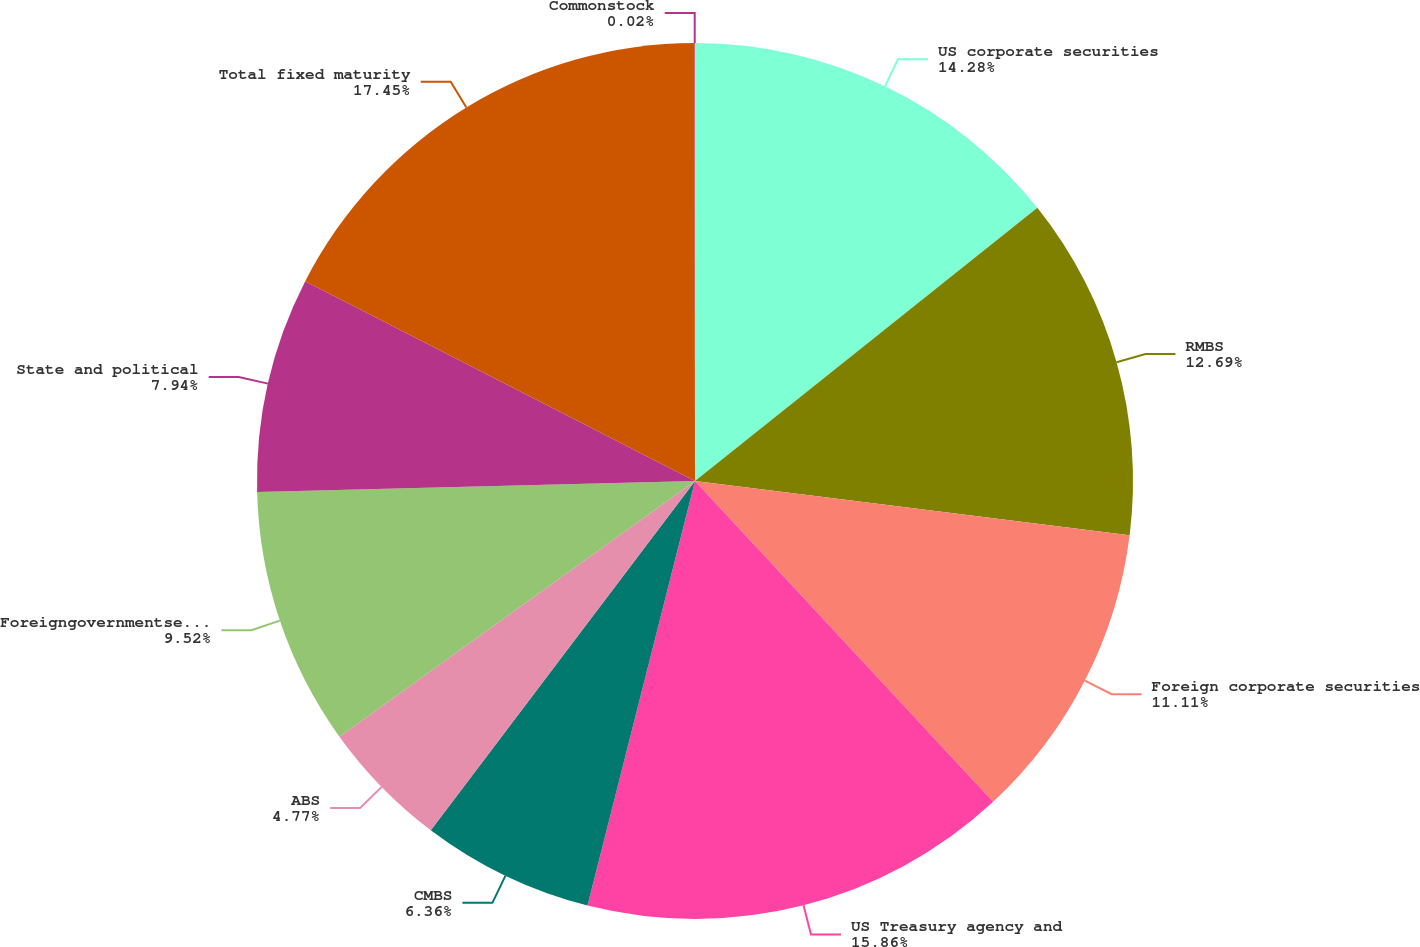Convert chart to OTSL. <chart><loc_0><loc_0><loc_500><loc_500><pie_chart><fcel>US corporate securities<fcel>RMBS<fcel>Foreign corporate securities<fcel>US Treasury agency and<fcel>CMBS<fcel>ABS<fcel>Foreigngovernmentsecurities<fcel>State and political<fcel>Total fixed maturity<fcel>Commonstock<nl><fcel>14.28%<fcel>12.69%<fcel>11.11%<fcel>15.86%<fcel>6.36%<fcel>4.77%<fcel>9.52%<fcel>7.94%<fcel>17.44%<fcel>0.02%<nl></chart> 